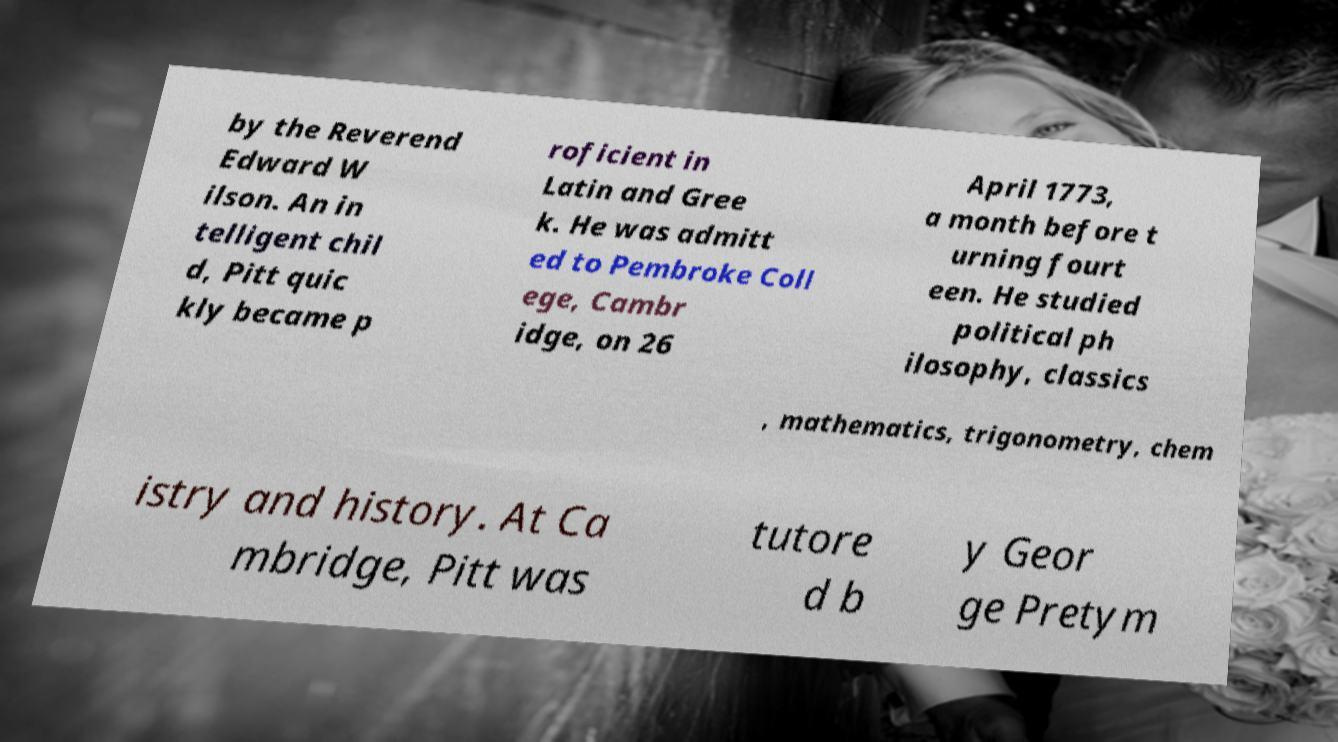There's text embedded in this image that I need extracted. Can you transcribe it verbatim? by the Reverend Edward W ilson. An in telligent chil d, Pitt quic kly became p roficient in Latin and Gree k. He was admitt ed to Pembroke Coll ege, Cambr idge, on 26 April 1773, a month before t urning fourt een. He studied political ph ilosophy, classics , mathematics, trigonometry, chem istry and history. At Ca mbridge, Pitt was tutore d b y Geor ge Pretym 